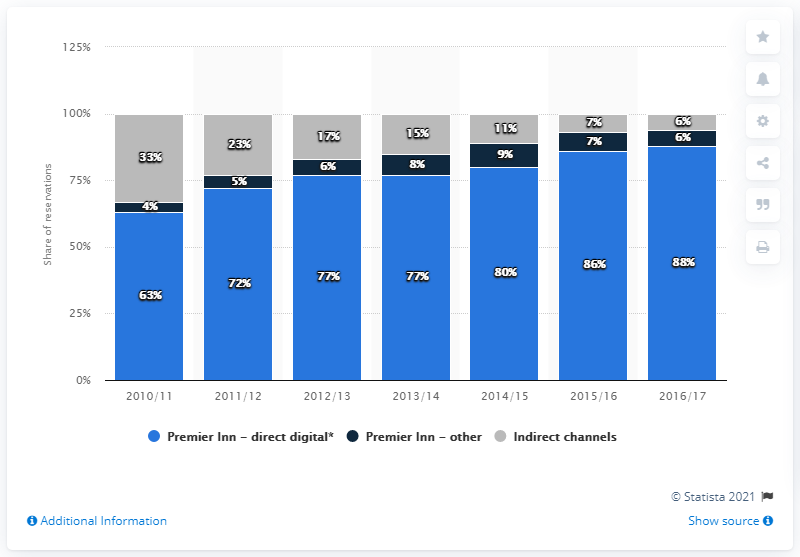Mention a couple of crucial points in this snapshot. I'm sorry, but I don't understand the context or information you are referring to in your question. Could you please provide more information or clarify your question? The "Premier Inn - Other" category consistently has a value below 10% for all years. 